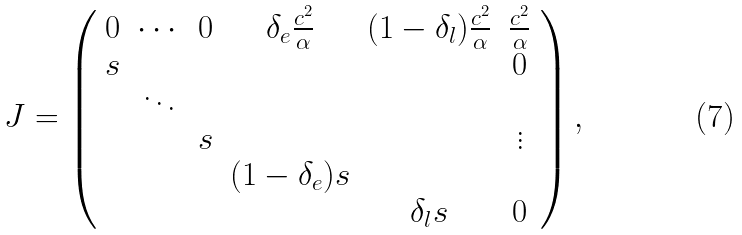<formula> <loc_0><loc_0><loc_500><loc_500>J = \left ( \begin{array} { c c c c c c c c } 0 & \cdots & 0 & \delta _ { e } \frac { c ^ { 2 } } { \alpha } & ( 1 - \delta _ { l } ) \frac { c ^ { 2 } } { \alpha } & \frac { c ^ { 2 } } { \alpha } \\ s & & & & & 0 \\ & \ddots & & & & \\ & & s & & & \vdots \\ & & & ( 1 - \delta _ { e } ) s & & \\ & & & & \delta _ { l } s & 0 \end{array} \right ) ,</formula> 